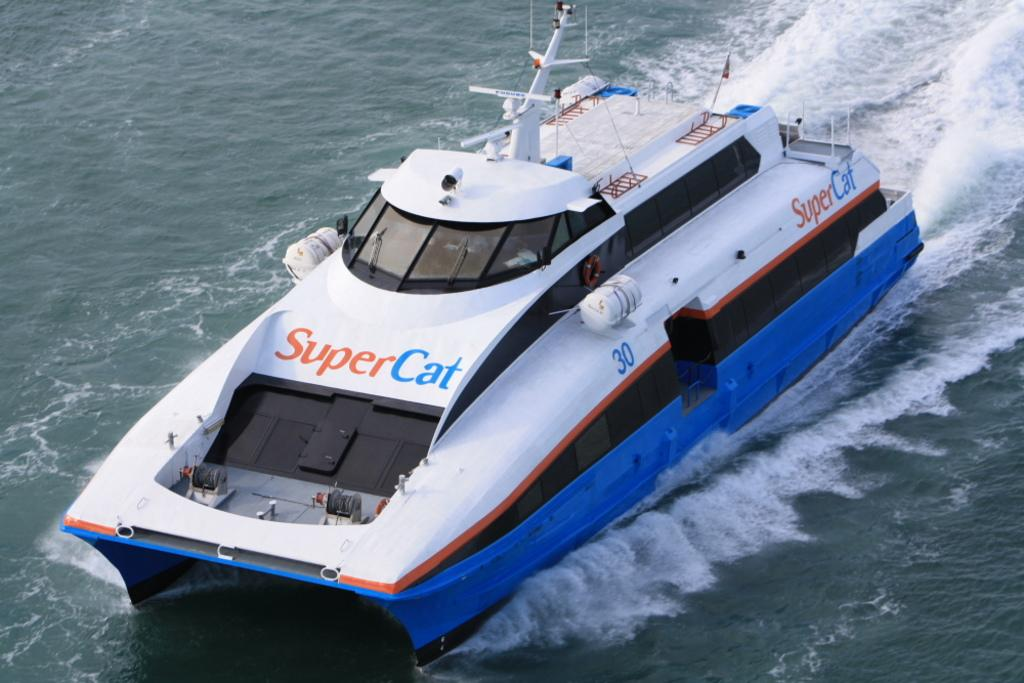Provide a one-sentence caption for the provided image. The name of the blue and white boat is Super Cat. 